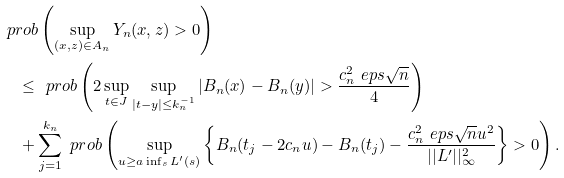Convert formula to latex. <formula><loc_0><loc_0><loc_500><loc_500>& \ p r o b \left ( \sup _ { ( x , z ) \in A _ { n } } Y _ { n } ( x , z ) > 0 \right ) \\ & \quad \leq \ p r o b \left ( 2 \sup _ { t \in J } \sup _ { | t - y | \leq k _ { n } ^ { - 1 } } \left | B _ { n } ( x ) - B _ { n } ( y ) \right | > \frac { c _ { n } ^ { 2 } \ e p s \sqrt { n } } { 4 } \right ) \\ & \quad + \sum _ { j = 1 } ^ { k _ { n } } \ p r o b \left ( \sup _ { u \geq a \inf _ { s } L ^ { \prime } ( s ) } \left \{ B _ { n } ( t _ { j } - 2 c _ { n } u ) - B _ { n } ( t _ { j } ) - \frac { c _ { n } ^ { 2 } \ e p s \sqrt { n } u ^ { 2 } } { | | L ^ { \prime } | | _ { \infty } ^ { 2 } } \right \} > 0 \right ) .</formula> 